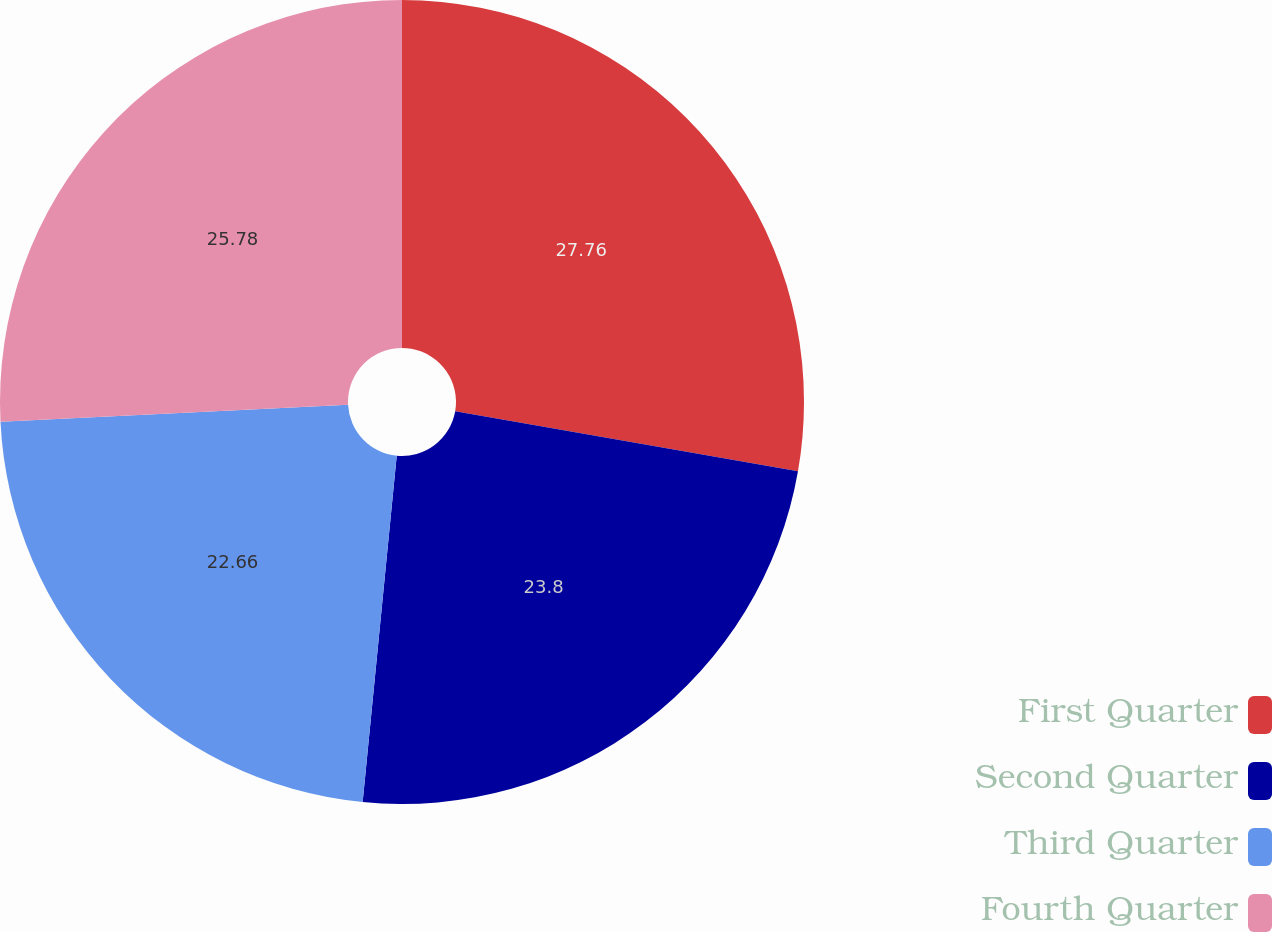Convert chart. <chart><loc_0><loc_0><loc_500><loc_500><pie_chart><fcel>First Quarter<fcel>Second Quarter<fcel>Third Quarter<fcel>Fourth Quarter<nl><fcel>27.76%<fcel>23.8%<fcel>22.66%<fcel>25.78%<nl></chart> 